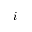<formula> <loc_0><loc_0><loc_500><loc_500>i</formula> 